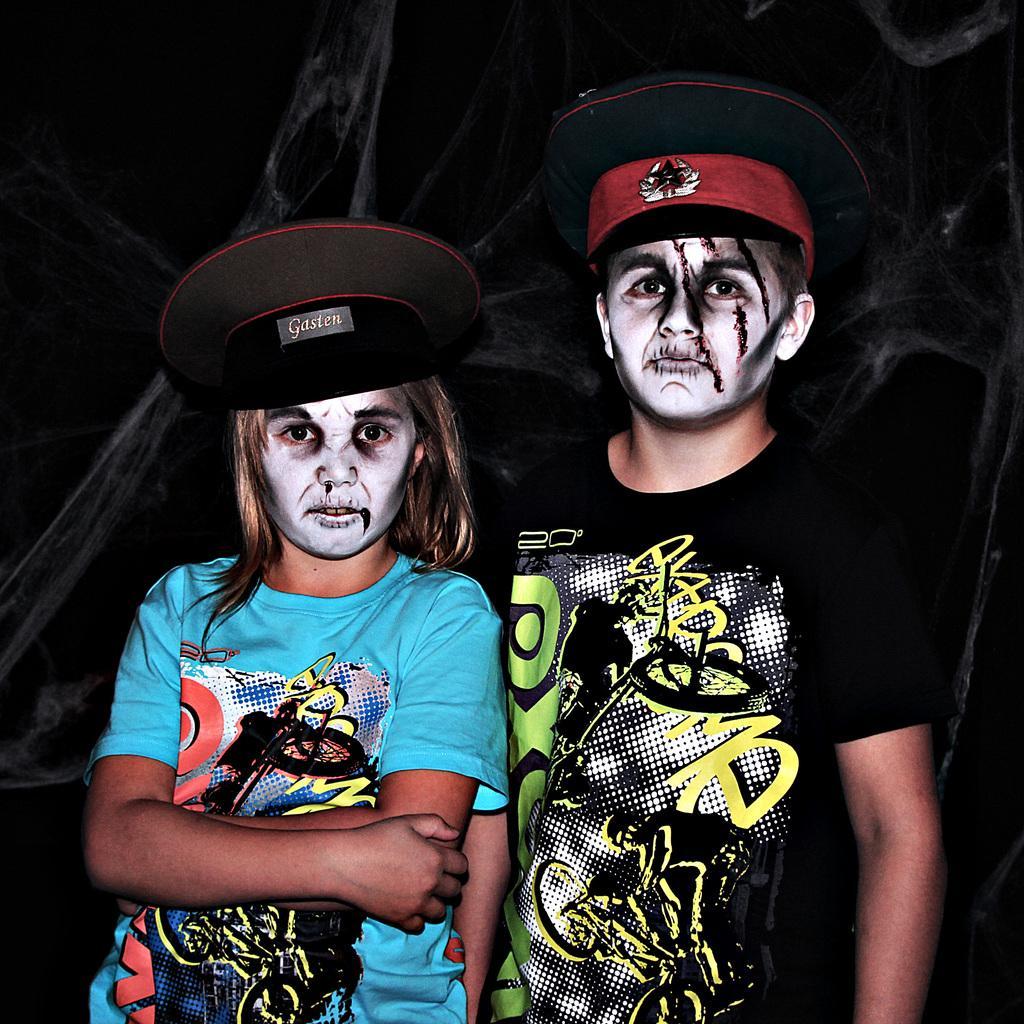In one or two sentences, can you explain what this image depicts? In this picture we can see a boy wearing black color t-shirt, hat and standing on the ground. On the left there is a girl wearing blue color t-shirt, hat and standing on the ground. In the background there are some objects. 